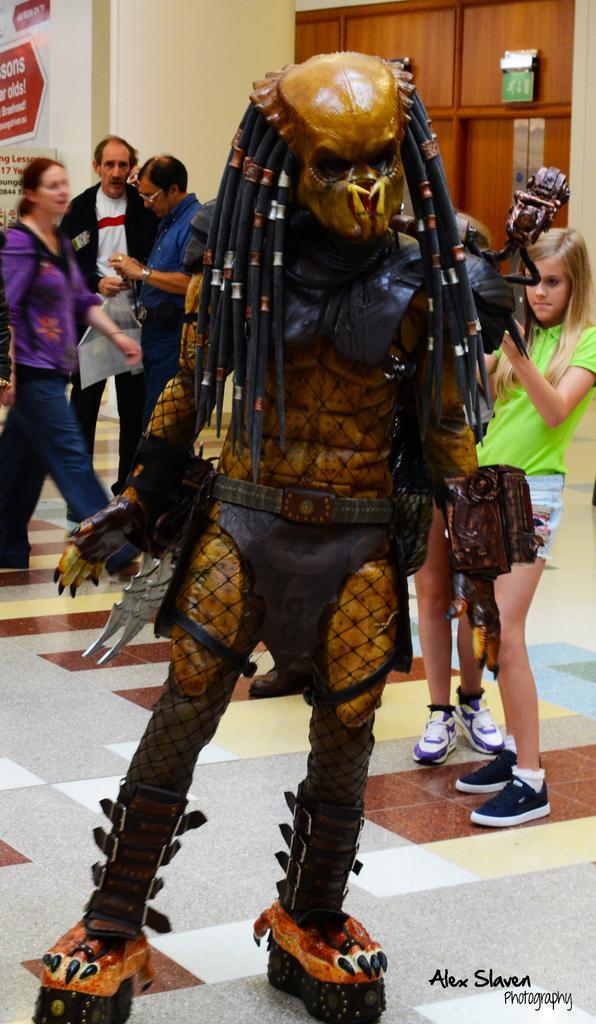In one or two sentences, can you explain what this image depicts? In this image we can see a toy which resembles a person. There are few people in the image. There is an advertising board at the left side of the image. 